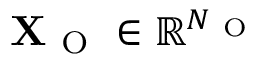<formula> <loc_0><loc_0><loc_500><loc_500>X _ { O } \in \mathbb { R } ^ { N _ { O } }</formula> 